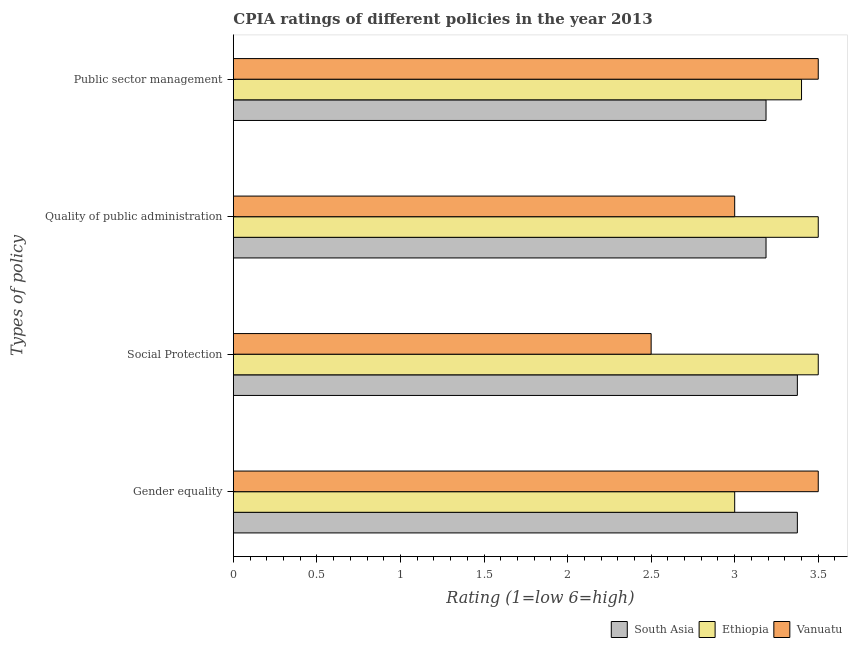How many groups of bars are there?
Provide a short and direct response. 4. Are the number of bars per tick equal to the number of legend labels?
Ensure brevity in your answer.  Yes. Are the number of bars on each tick of the Y-axis equal?
Make the answer very short. Yes. What is the label of the 4th group of bars from the top?
Make the answer very short. Gender equality. What is the cpia rating of public sector management in South Asia?
Ensure brevity in your answer.  3.19. Across all countries, what is the minimum cpia rating of public sector management?
Ensure brevity in your answer.  3.19. In which country was the cpia rating of quality of public administration maximum?
Your response must be concise. Ethiopia. In which country was the cpia rating of social protection minimum?
Make the answer very short. Vanuatu. What is the total cpia rating of public sector management in the graph?
Your answer should be compact. 10.09. What is the difference between the cpia rating of social protection in Vanuatu and that in Ethiopia?
Offer a very short reply. -1. What is the difference between the cpia rating of public sector management in Ethiopia and the cpia rating of social protection in Vanuatu?
Ensure brevity in your answer.  0.9. What is the average cpia rating of public sector management per country?
Your answer should be compact. 3.36. What is the difference between the cpia rating of gender equality and cpia rating of public sector management in Vanuatu?
Your answer should be compact. 0. What is the ratio of the cpia rating of social protection in Ethiopia to that in South Asia?
Offer a very short reply. 1.04. What is the difference between the highest and the second highest cpia rating of quality of public administration?
Your response must be concise. 0.31. What is the difference between the highest and the lowest cpia rating of quality of public administration?
Provide a short and direct response. 0.5. What does the 2nd bar from the top in Gender equality represents?
Your answer should be compact. Ethiopia. What does the 2nd bar from the bottom in Public sector management represents?
Provide a succinct answer. Ethiopia. How many bars are there?
Provide a succinct answer. 12. Are all the bars in the graph horizontal?
Give a very brief answer. Yes. Does the graph contain any zero values?
Your answer should be very brief. No. Where does the legend appear in the graph?
Your answer should be very brief. Bottom right. What is the title of the graph?
Offer a very short reply. CPIA ratings of different policies in the year 2013. Does "Slovak Republic" appear as one of the legend labels in the graph?
Provide a short and direct response. No. What is the label or title of the X-axis?
Ensure brevity in your answer.  Rating (1=low 6=high). What is the label or title of the Y-axis?
Provide a short and direct response. Types of policy. What is the Rating (1=low 6=high) of South Asia in Gender equality?
Provide a succinct answer. 3.38. What is the Rating (1=low 6=high) in Ethiopia in Gender equality?
Your answer should be very brief. 3. What is the Rating (1=low 6=high) in South Asia in Social Protection?
Offer a very short reply. 3.38. What is the Rating (1=low 6=high) in Ethiopia in Social Protection?
Your answer should be compact. 3.5. What is the Rating (1=low 6=high) of Vanuatu in Social Protection?
Offer a very short reply. 2.5. What is the Rating (1=low 6=high) in South Asia in Quality of public administration?
Offer a terse response. 3.19. What is the Rating (1=low 6=high) of Ethiopia in Quality of public administration?
Offer a very short reply. 3.5. What is the Rating (1=low 6=high) in Vanuatu in Quality of public administration?
Keep it short and to the point. 3. What is the Rating (1=low 6=high) of South Asia in Public sector management?
Your answer should be compact. 3.19. What is the Rating (1=low 6=high) of Vanuatu in Public sector management?
Your response must be concise. 3.5. Across all Types of policy, what is the maximum Rating (1=low 6=high) in South Asia?
Your response must be concise. 3.38. Across all Types of policy, what is the maximum Rating (1=low 6=high) in Vanuatu?
Provide a succinct answer. 3.5. Across all Types of policy, what is the minimum Rating (1=low 6=high) of South Asia?
Your answer should be compact. 3.19. Across all Types of policy, what is the minimum Rating (1=low 6=high) of Ethiopia?
Ensure brevity in your answer.  3. Across all Types of policy, what is the minimum Rating (1=low 6=high) of Vanuatu?
Your response must be concise. 2.5. What is the total Rating (1=low 6=high) of South Asia in the graph?
Your response must be concise. 13.12. What is the difference between the Rating (1=low 6=high) in South Asia in Gender equality and that in Social Protection?
Offer a very short reply. 0. What is the difference between the Rating (1=low 6=high) in South Asia in Gender equality and that in Quality of public administration?
Your answer should be compact. 0.19. What is the difference between the Rating (1=low 6=high) in Ethiopia in Gender equality and that in Quality of public administration?
Your response must be concise. -0.5. What is the difference between the Rating (1=low 6=high) of Vanuatu in Gender equality and that in Quality of public administration?
Provide a succinct answer. 0.5. What is the difference between the Rating (1=low 6=high) in South Asia in Gender equality and that in Public sector management?
Give a very brief answer. 0.19. What is the difference between the Rating (1=low 6=high) in Vanuatu in Gender equality and that in Public sector management?
Give a very brief answer. 0. What is the difference between the Rating (1=low 6=high) of South Asia in Social Protection and that in Quality of public administration?
Make the answer very short. 0.19. What is the difference between the Rating (1=low 6=high) in Vanuatu in Social Protection and that in Quality of public administration?
Keep it short and to the point. -0.5. What is the difference between the Rating (1=low 6=high) of South Asia in Social Protection and that in Public sector management?
Ensure brevity in your answer.  0.19. What is the difference between the Rating (1=low 6=high) of Ethiopia in Social Protection and that in Public sector management?
Give a very brief answer. 0.1. What is the difference between the Rating (1=low 6=high) in South Asia in Quality of public administration and that in Public sector management?
Make the answer very short. 0. What is the difference between the Rating (1=low 6=high) of Ethiopia in Quality of public administration and that in Public sector management?
Your answer should be compact. 0.1. What is the difference between the Rating (1=low 6=high) of Vanuatu in Quality of public administration and that in Public sector management?
Offer a very short reply. -0.5. What is the difference between the Rating (1=low 6=high) of South Asia in Gender equality and the Rating (1=low 6=high) of Ethiopia in Social Protection?
Your answer should be compact. -0.12. What is the difference between the Rating (1=low 6=high) of South Asia in Gender equality and the Rating (1=low 6=high) of Vanuatu in Social Protection?
Provide a succinct answer. 0.88. What is the difference between the Rating (1=low 6=high) of Ethiopia in Gender equality and the Rating (1=low 6=high) of Vanuatu in Social Protection?
Offer a terse response. 0.5. What is the difference between the Rating (1=low 6=high) in South Asia in Gender equality and the Rating (1=low 6=high) in Ethiopia in Quality of public administration?
Offer a very short reply. -0.12. What is the difference between the Rating (1=low 6=high) in Ethiopia in Gender equality and the Rating (1=low 6=high) in Vanuatu in Quality of public administration?
Give a very brief answer. 0. What is the difference between the Rating (1=low 6=high) in South Asia in Gender equality and the Rating (1=low 6=high) in Ethiopia in Public sector management?
Keep it short and to the point. -0.03. What is the difference between the Rating (1=low 6=high) of South Asia in Gender equality and the Rating (1=low 6=high) of Vanuatu in Public sector management?
Your response must be concise. -0.12. What is the difference between the Rating (1=low 6=high) in South Asia in Social Protection and the Rating (1=low 6=high) in Ethiopia in Quality of public administration?
Provide a succinct answer. -0.12. What is the difference between the Rating (1=low 6=high) in South Asia in Social Protection and the Rating (1=low 6=high) in Vanuatu in Quality of public administration?
Provide a short and direct response. 0.38. What is the difference between the Rating (1=low 6=high) in Ethiopia in Social Protection and the Rating (1=low 6=high) in Vanuatu in Quality of public administration?
Your answer should be very brief. 0.5. What is the difference between the Rating (1=low 6=high) of South Asia in Social Protection and the Rating (1=low 6=high) of Ethiopia in Public sector management?
Ensure brevity in your answer.  -0.03. What is the difference between the Rating (1=low 6=high) of South Asia in Social Protection and the Rating (1=low 6=high) of Vanuatu in Public sector management?
Your answer should be very brief. -0.12. What is the difference between the Rating (1=low 6=high) in Ethiopia in Social Protection and the Rating (1=low 6=high) in Vanuatu in Public sector management?
Provide a succinct answer. 0. What is the difference between the Rating (1=low 6=high) in South Asia in Quality of public administration and the Rating (1=low 6=high) in Ethiopia in Public sector management?
Your answer should be compact. -0.21. What is the difference between the Rating (1=low 6=high) of South Asia in Quality of public administration and the Rating (1=low 6=high) of Vanuatu in Public sector management?
Give a very brief answer. -0.31. What is the average Rating (1=low 6=high) in South Asia per Types of policy?
Offer a very short reply. 3.28. What is the average Rating (1=low 6=high) in Ethiopia per Types of policy?
Make the answer very short. 3.35. What is the average Rating (1=low 6=high) in Vanuatu per Types of policy?
Provide a succinct answer. 3.12. What is the difference between the Rating (1=low 6=high) of South Asia and Rating (1=low 6=high) of Vanuatu in Gender equality?
Provide a succinct answer. -0.12. What is the difference between the Rating (1=low 6=high) in South Asia and Rating (1=low 6=high) in Ethiopia in Social Protection?
Offer a very short reply. -0.12. What is the difference between the Rating (1=low 6=high) in South Asia and Rating (1=low 6=high) in Vanuatu in Social Protection?
Give a very brief answer. 0.88. What is the difference between the Rating (1=low 6=high) in South Asia and Rating (1=low 6=high) in Ethiopia in Quality of public administration?
Your answer should be compact. -0.31. What is the difference between the Rating (1=low 6=high) of South Asia and Rating (1=low 6=high) of Vanuatu in Quality of public administration?
Ensure brevity in your answer.  0.19. What is the difference between the Rating (1=low 6=high) in South Asia and Rating (1=low 6=high) in Ethiopia in Public sector management?
Your answer should be very brief. -0.21. What is the difference between the Rating (1=low 6=high) in South Asia and Rating (1=low 6=high) in Vanuatu in Public sector management?
Provide a short and direct response. -0.31. What is the ratio of the Rating (1=low 6=high) in South Asia in Gender equality to that in Social Protection?
Your response must be concise. 1. What is the ratio of the Rating (1=low 6=high) in Ethiopia in Gender equality to that in Social Protection?
Your answer should be compact. 0.86. What is the ratio of the Rating (1=low 6=high) of Vanuatu in Gender equality to that in Social Protection?
Offer a very short reply. 1.4. What is the ratio of the Rating (1=low 6=high) of South Asia in Gender equality to that in Quality of public administration?
Make the answer very short. 1.06. What is the ratio of the Rating (1=low 6=high) of Ethiopia in Gender equality to that in Quality of public administration?
Make the answer very short. 0.86. What is the ratio of the Rating (1=low 6=high) in South Asia in Gender equality to that in Public sector management?
Ensure brevity in your answer.  1.06. What is the ratio of the Rating (1=low 6=high) in Ethiopia in Gender equality to that in Public sector management?
Make the answer very short. 0.88. What is the ratio of the Rating (1=low 6=high) in Vanuatu in Gender equality to that in Public sector management?
Offer a very short reply. 1. What is the ratio of the Rating (1=low 6=high) in South Asia in Social Protection to that in Quality of public administration?
Your response must be concise. 1.06. What is the ratio of the Rating (1=low 6=high) of Vanuatu in Social Protection to that in Quality of public administration?
Your answer should be very brief. 0.83. What is the ratio of the Rating (1=low 6=high) in South Asia in Social Protection to that in Public sector management?
Provide a short and direct response. 1.06. What is the ratio of the Rating (1=low 6=high) of Ethiopia in Social Protection to that in Public sector management?
Provide a short and direct response. 1.03. What is the ratio of the Rating (1=low 6=high) of Vanuatu in Social Protection to that in Public sector management?
Your answer should be very brief. 0.71. What is the ratio of the Rating (1=low 6=high) of Ethiopia in Quality of public administration to that in Public sector management?
Ensure brevity in your answer.  1.03. What is the ratio of the Rating (1=low 6=high) of Vanuatu in Quality of public administration to that in Public sector management?
Make the answer very short. 0.86. What is the difference between the highest and the second highest Rating (1=low 6=high) of South Asia?
Your response must be concise. 0. What is the difference between the highest and the second highest Rating (1=low 6=high) of Ethiopia?
Make the answer very short. 0. What is the difference between the highest and the second highest Rating (1=low 6=high) of Vanuatu?
Your answer should be very brief. 0. What is the difference between the highest and the lowest Rating (1=low 6=high) in South Asia?
Offer a very short reply. 0.19. What is the difference between the highest and the lowest Rating (1=low 6=high) in Ethiopia?
Your answer should be compact. 0.5. What is the difference between the highest and the lowest Rating (1=low 6=high) of Vanuatu?
Your answer should be very brief. 1. 